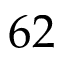Convert formula to latex. <formula><loc_0><loc_0><loc_500><loc_500>6 2</formula> 